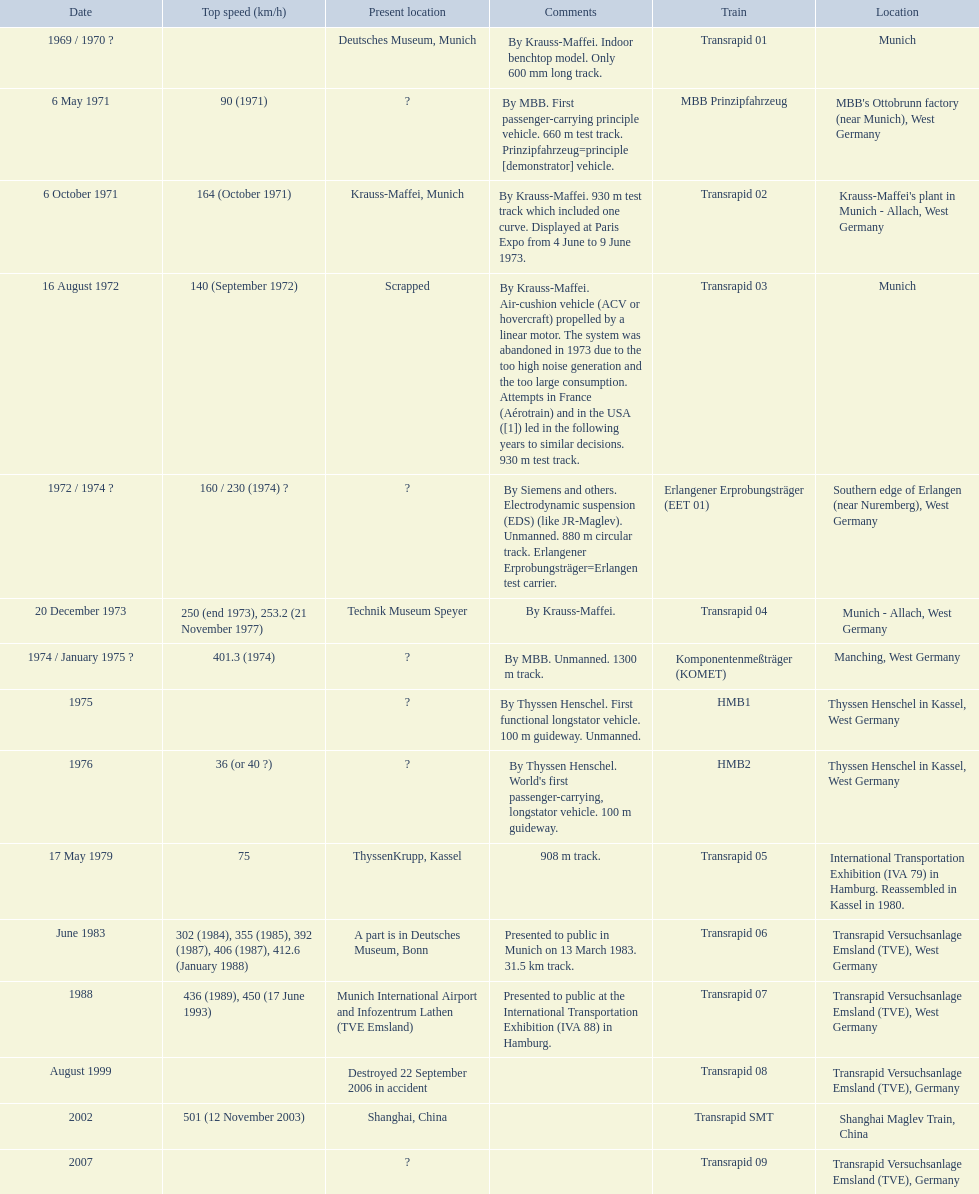Which trains exceeded a top speed of 400+? Komponentenmeßträger (KOMET), Transrapid 07, Transrapid SMT. How about 500+? Transrapid SMT. 